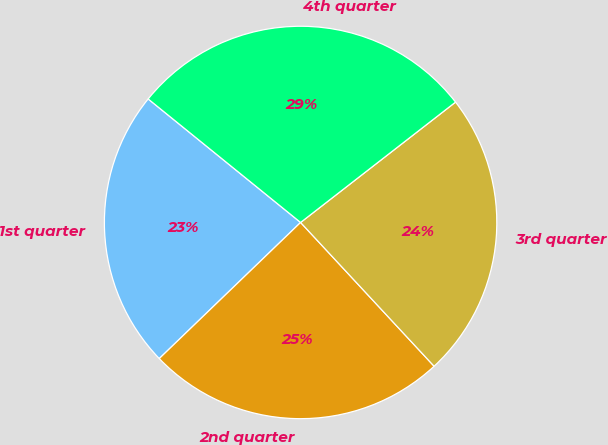Convert chart. <chart><loc_0><loc_0><loc_500><loc_500><pie_chart><fcel>1st quarter<fcel>2nd quarter<fcel>3rd quarter<fcel>4th quarter<nl><fcel>23.04%<fcel>24.71%<fcel>23.6%<fcel>28.65%<nl></chart> 